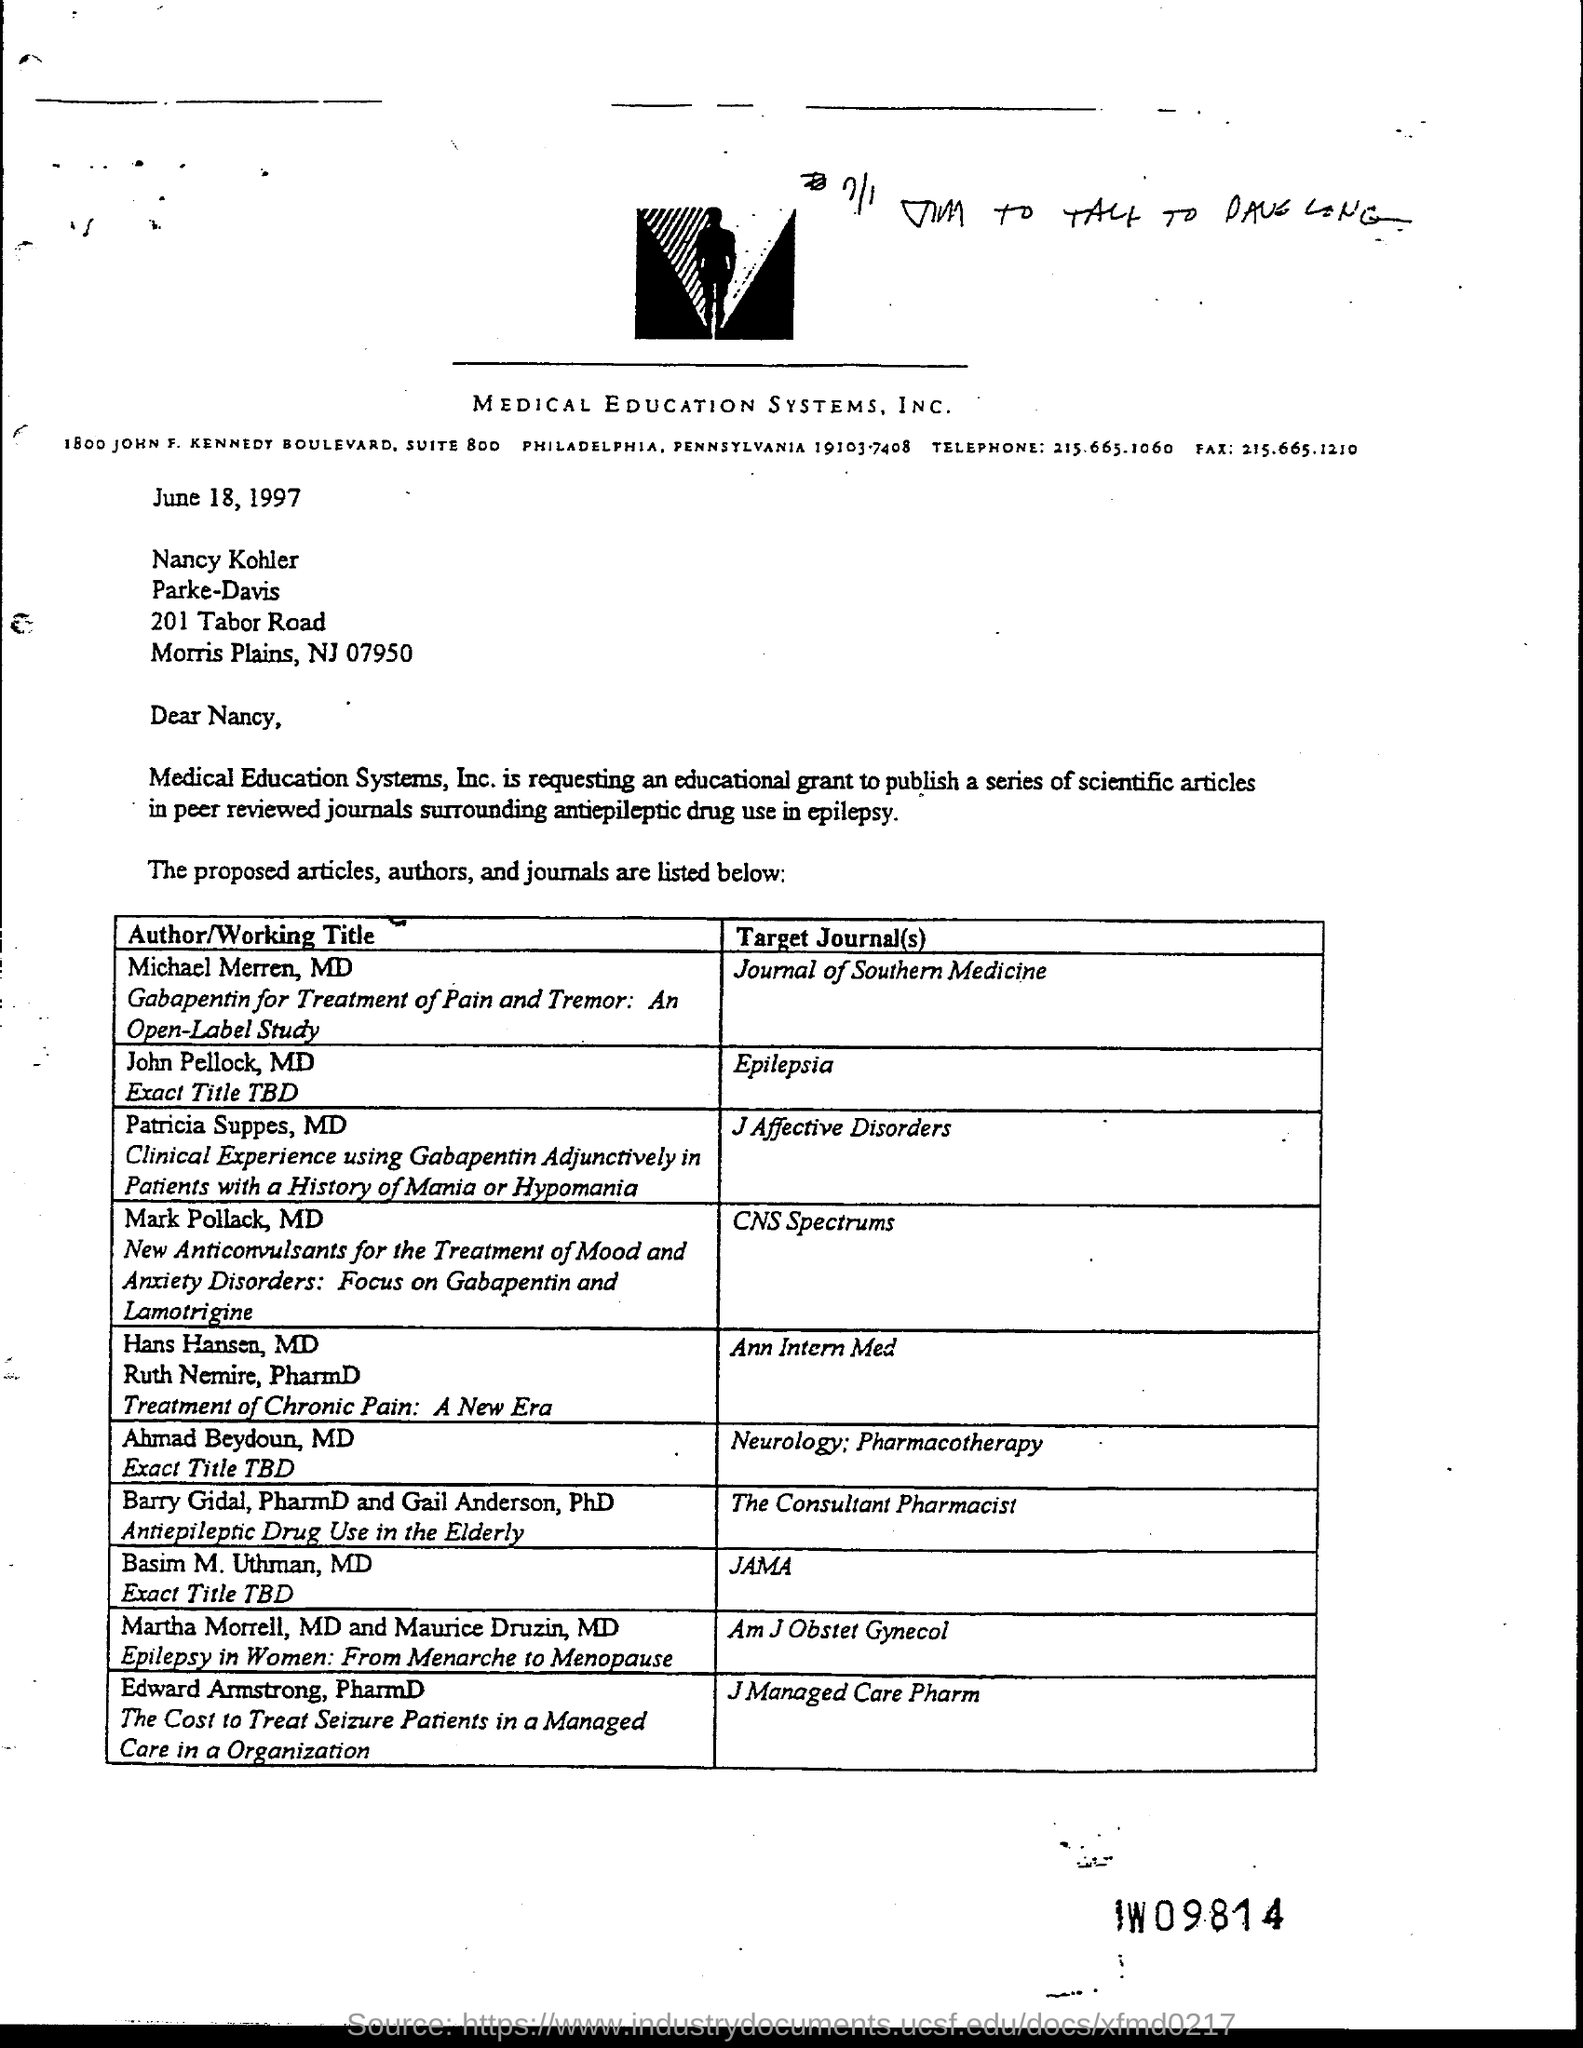Which company is mentioned in the letter head?
Make the answer very short. MEDICAL EDUCATION SYSTEMS, INC. What is the date mentioned in this letter?
Keep it short and to the point. June 18, 1997. Who is the Author of the article titled 'Gabapentin for Treatment of Pain and  Tremor : An Open-Label Study'?
Make the answer very short. Michael Merren, MD. 